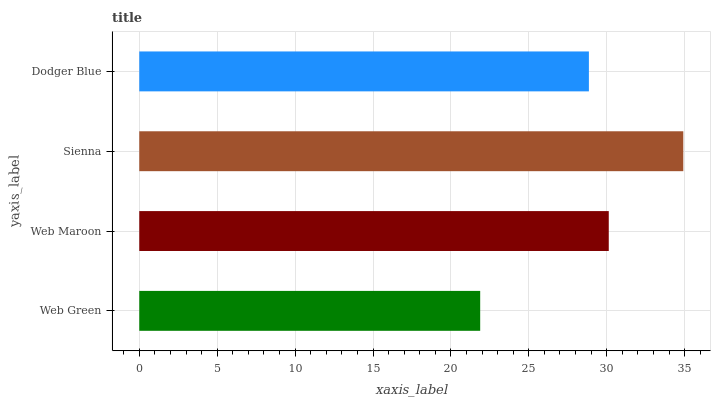Is Web Green the minimum?
Answer yes or no. Yes. Is Sienna the maximum?
Answer yes or no. Yes. Is Web Maroon the minimum?
Answer yes or no. No. Is Web Maroon the maximum?
Answer yes or no. No. Is Web Maroon greater than Web Green?
Answer yes or no. Yes. Is Web Green less than Web Maroon?
Answer yes or no. Yes. Is Web Green greater than Web Maroon?
Answer yes or no. No. Is Web Maroon less than Web Green?
Answer yes or no. No. Is Web Maroon the high median?
Answer yes or no. Yes. Is Dodger Blue the low median?
Answer yes or no. Yes. Is Web Green the high median?
Answer yes or no. No. Is Sienna the low median?
Answer yes or no. No. 